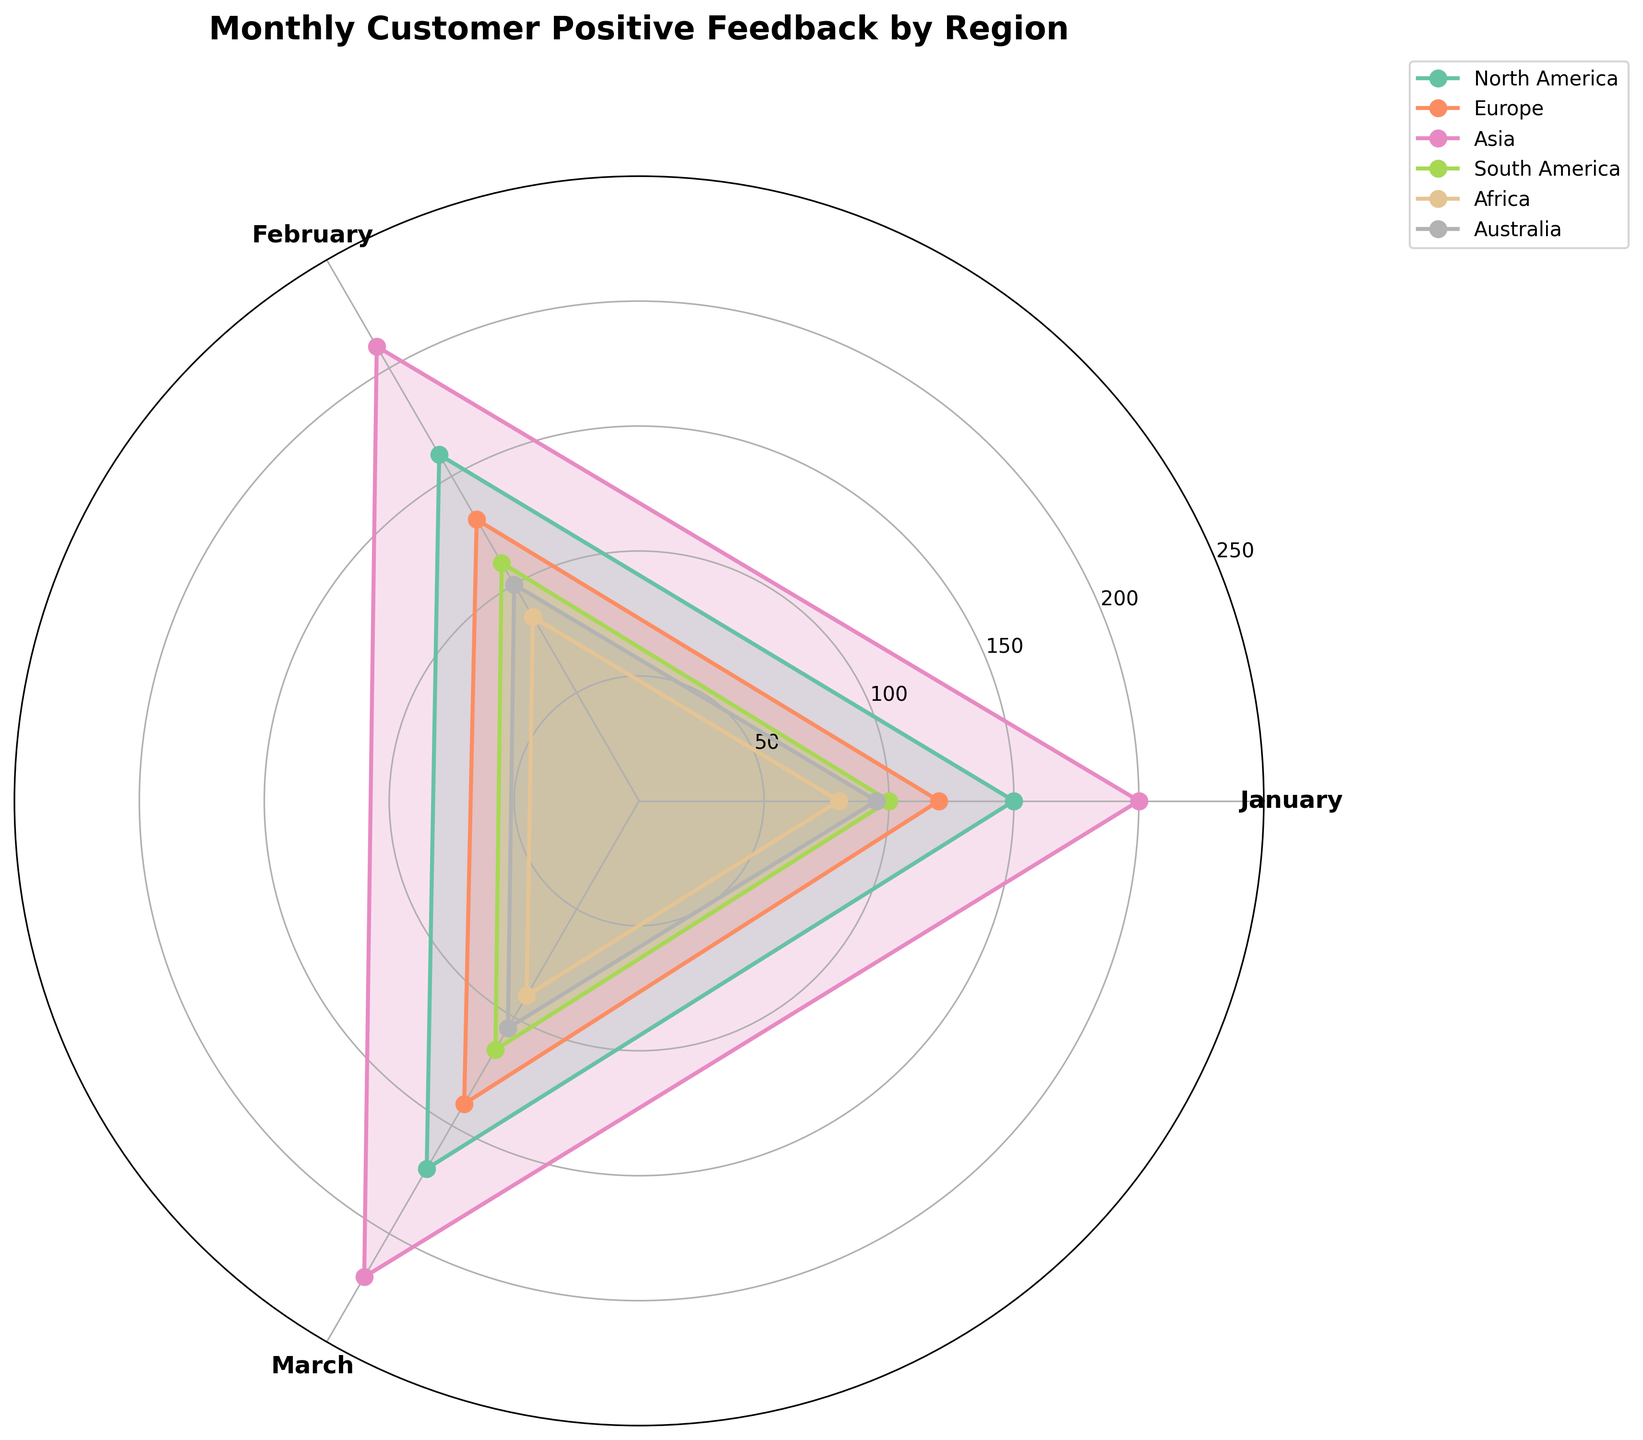What is the title of the chart? The chart title is located at the top and is usually displayed in larger, bold font. The title indicates the main subject of the chart.
Answer: Monthly Customer Positive Feedback by Region How many regions are displayed in the chart? By analyzing the legend on the right side of the plot, we can count the number of unique regions listed.
Answer: 6 What colors are used to represent the different regions? Observing the legend, we see that each region is assigned a unique color. These colors are used throughout the chart to differentiate the regions.
Answer: Various colors, one per region Which region received the highest positive feedback in March? By looking at the plot corresponding to March (position within the polar axis), we trace the radius lengths and determine which region's radial line extends the furthest.
Answer: Asia What is the average positive feedback received in February across all regions? Sum the positive feedback values for February from all regions and divide by the number of regions. (160+130+210+110+85+100)/6 = 132.5
Answer: 132.5 Which region had the smallest increase in positive feedback from February to March? To find the smallest increase, we calculate the difference in positive feedback between February and March for each region and identify the smallest value. 
(Asia: 220-210 = 10, Europe: 140-130 = 10, others similar steps)
Answer: Europe and Asia Which region showed the most consistent (least variable) positive feedback over the three months? Consistency can be interpreted as having the smallest range. We calculate the range (max - min) for each region across the three months and find the smallest range.
(Africa: max(90) - min(80) = 10, etc.)
Answer: Africa How does the positive feedback trend for North America change over the three months? Observing the North America line, we note the direction and magnitude of changes at each month's point.
Answer: Increasing Which month has the highest combined positive feedback across all regions? Sum all the regions' positive feedback values for each month and identify the month with the largest total.
(January: 150+120+200+100+80+95 = 745, others similar steps)
Answer: March What pattern do you observe in the positive feedback values for the Europe region over the three months? Checking the radial point values for Europe over the three months, we note how the values change and describe the overall trend.
Answer: Gradual increase 